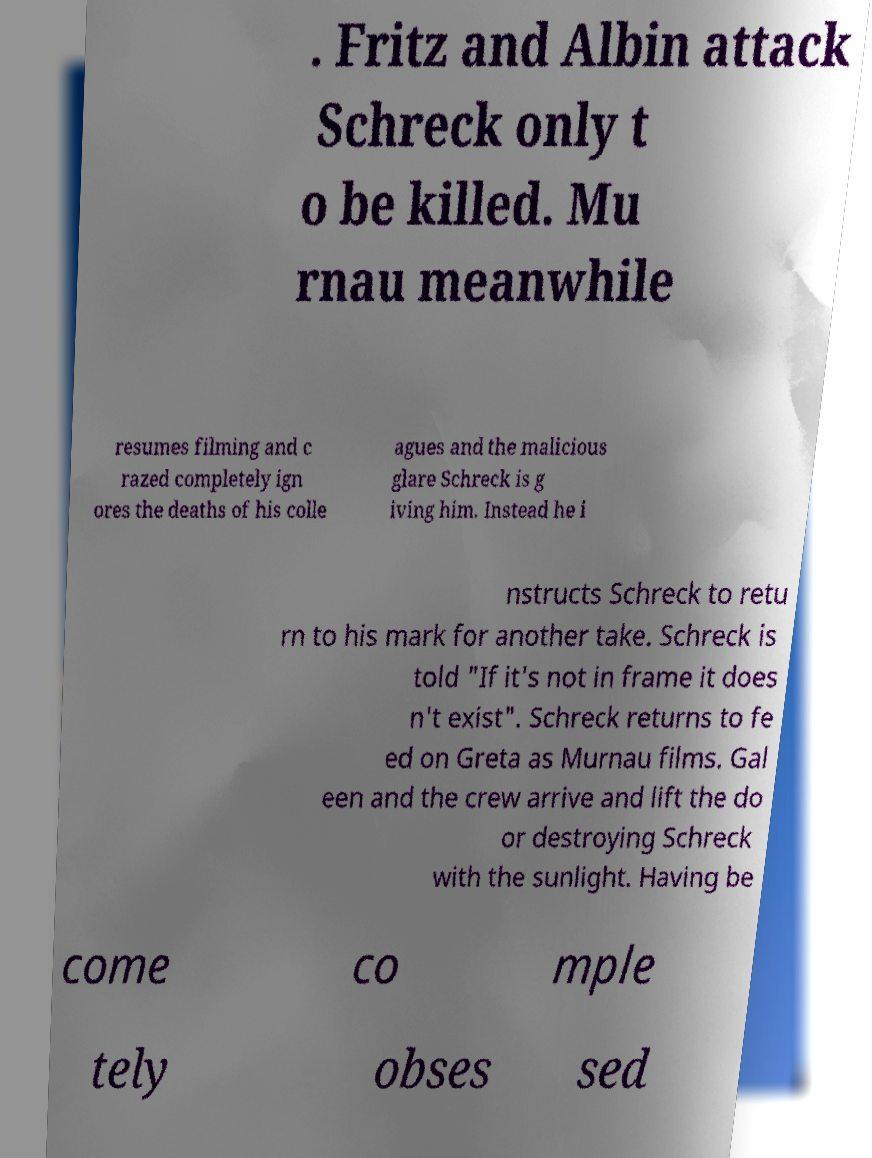What messages or text are displayed in this image? I need them in a readable, typed format. . Fritz and Albin attack Schreck only t o be killed. Mu rnau meanwhile resumes filming and c razed completely ign ores the deaths of his colle agues and the malicious glare Schreck is g iving him. Instead he i nstructs Schreck to retu rn to his mark for another take. Schreck is told "If it's not in frame it does n't exist". Schreck returns to fe ed on Greta as Murnau films. Gal een and the crew arrive and lift the do or destroying Schreck with the sunlight. Having be come co mple tely obses sed 